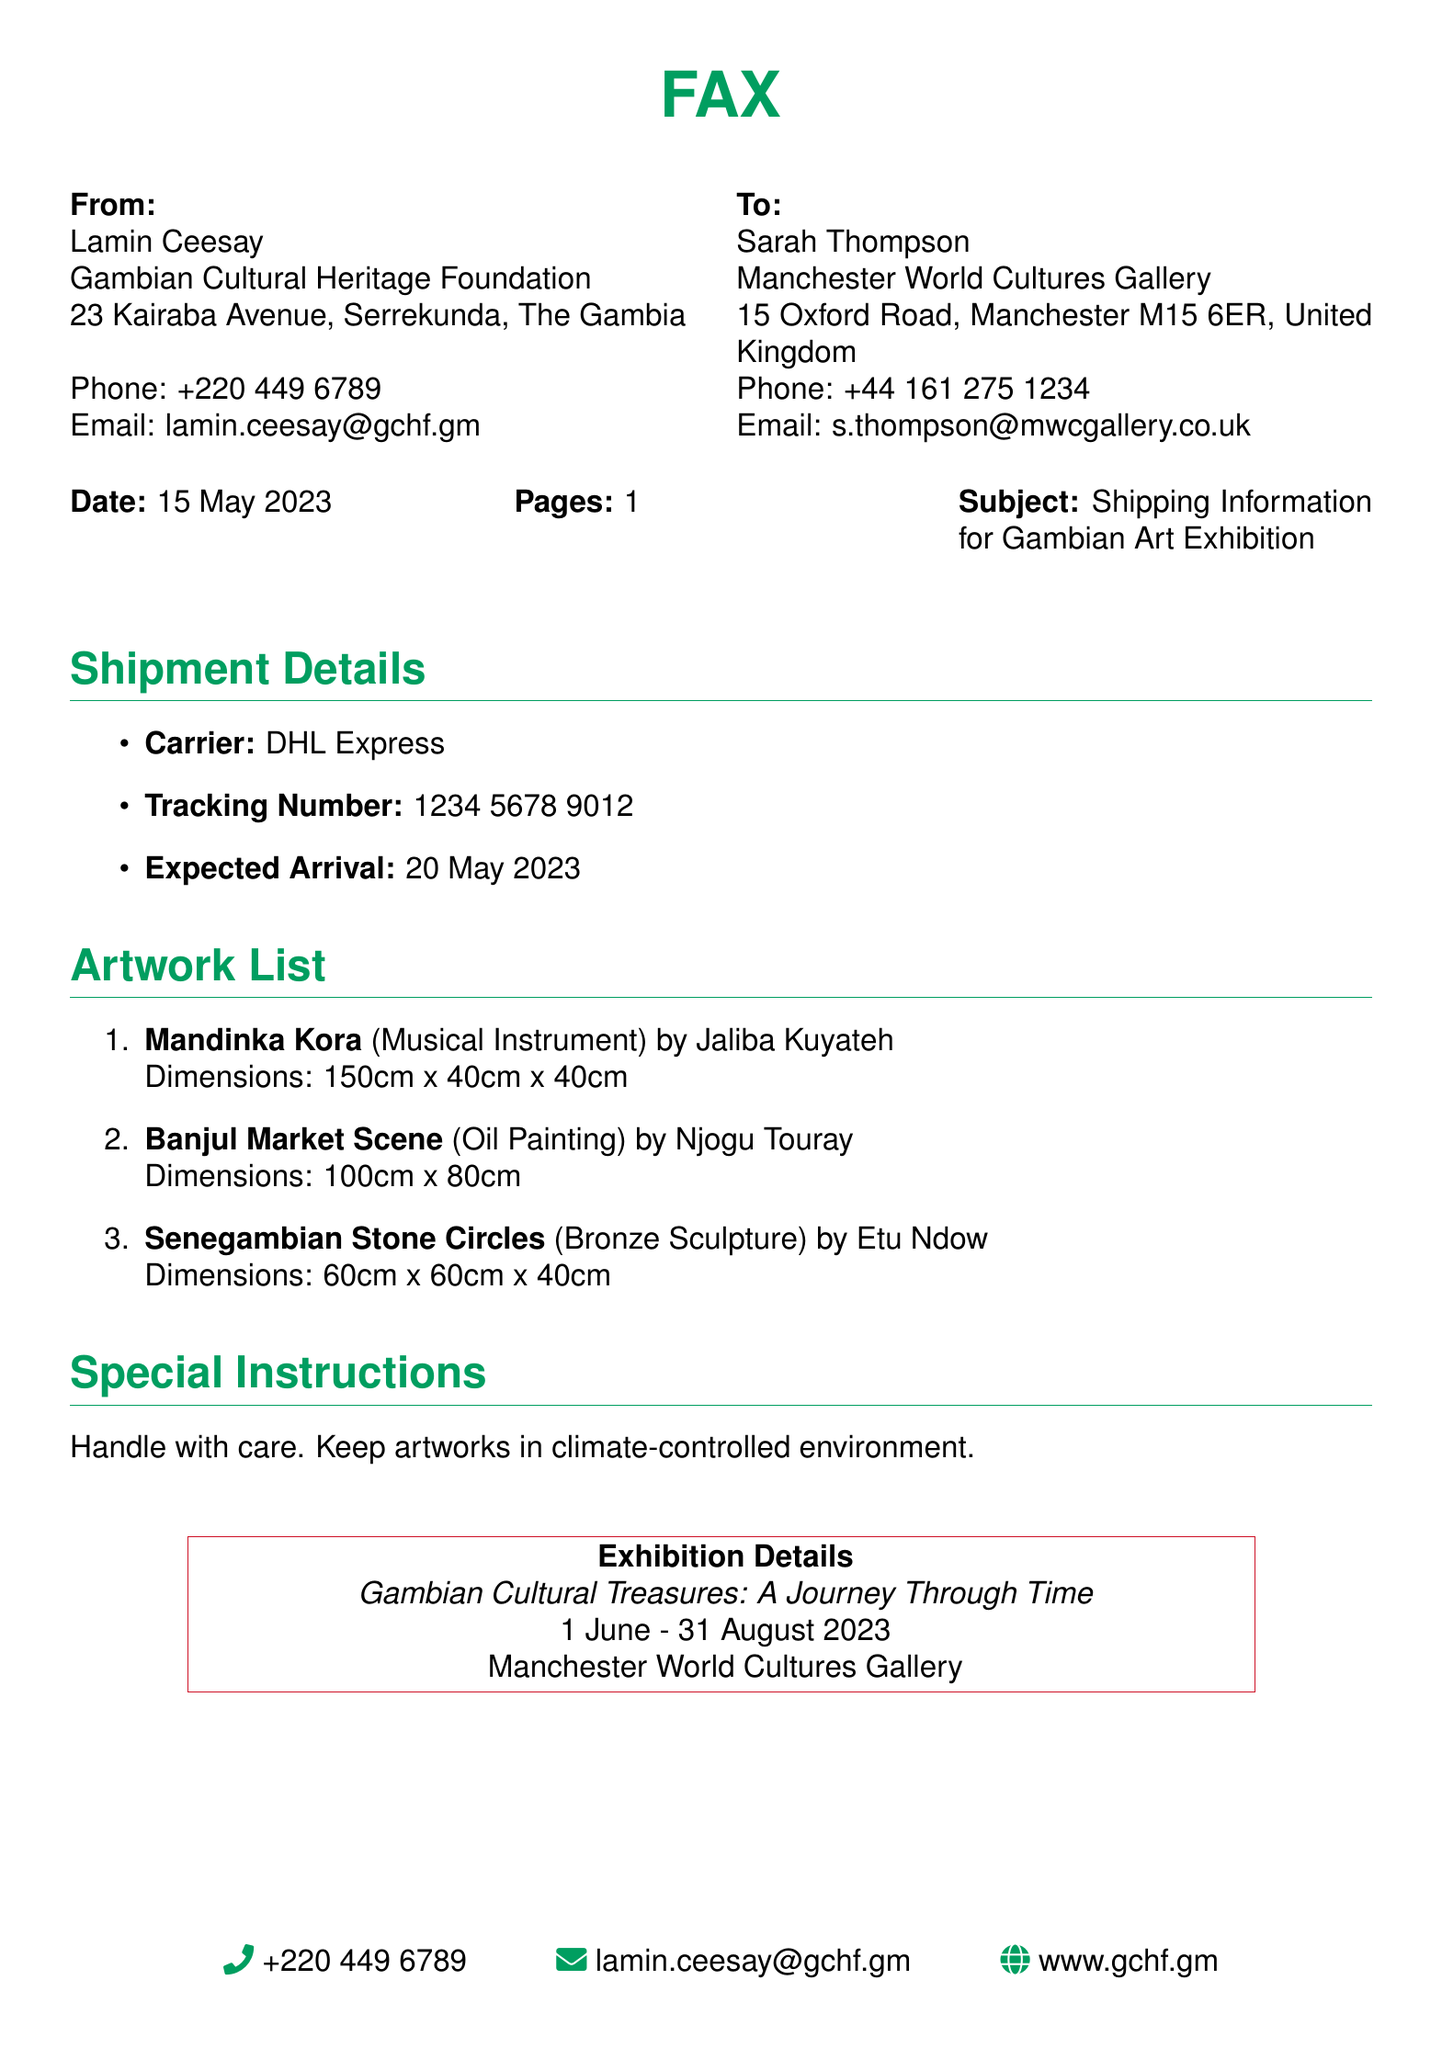what is the sender's name? The sender's name is listed at the top of the fax under "From."
Answer: Lamin Ceesay what is the recipient's email address? The recipient's email address is found under "To" in the fax.
Answer: s.thompson@mwcgallery.co.uk what is the tracking number for the shipment? The tracking number is specified in the "Shipment Details" section of the fax.
Answer: 1234 5678 9012 what is the expected arrival date of the shipment? The expected arrival date appears in the "Shipment Details" section.
Answer: 20 May 2023 which artwork is a musical instrument? The artworks are listed under "Artwork List," and one of them is recognized as a musical instrument.
Answer: Mandinka Kora how many artworks are mentioned in the document? The number of artworks can be counted from the list provided in the document.
Answer: 3 what special instruction is given for handling the artworks? The special instructions are found under "Special Instructions" in the document.
Answer: Handle with care what are the dates of the exhibition? The dates of the exhibition are mentioned under "Exhibition Details."
Answer: 1 June - 31 August 2023 what is the name of the exhibition? The name of the exhibition is highlighted in the "Exhibition Details" section.
Answer: Gambian Cultural Treasures: A Journey Through Time 